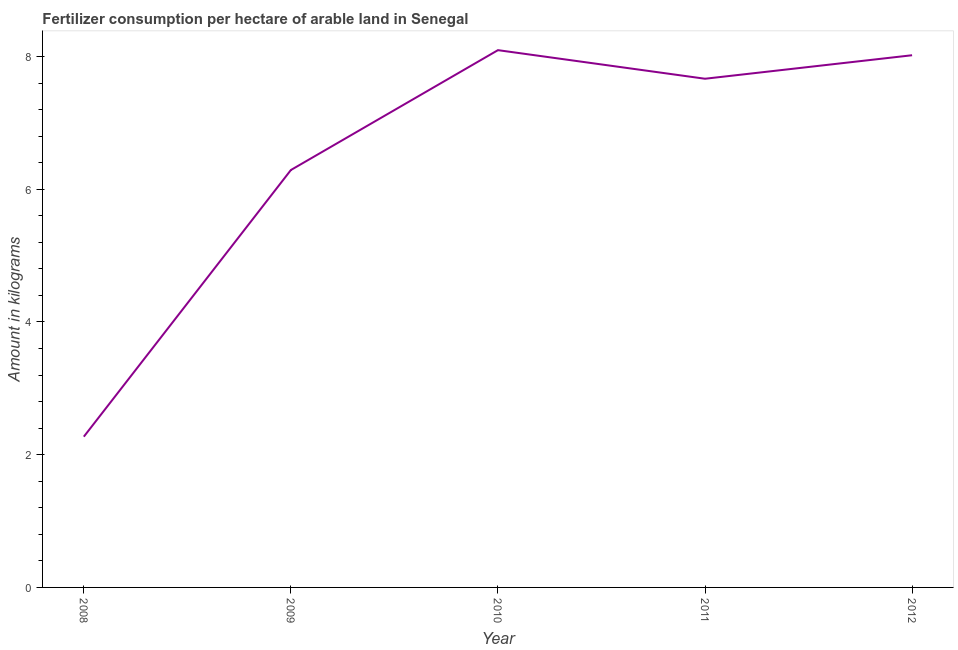What is the amount of fertilizer consumption in 2009?
Keep it short and to the point. 6.29. Across all years, what is the maximum amount of fertilizer consumption?
Provide a succinct answer. 8.1. Across all years, what is the minimum amount of fertilizer consumption?
Make the answer very short. 2.27. In which year was the amount of fertilizer consumption maximum?
Offer a very short reply. 2010. In which year was the amount of fertilizer consumption minimum?
Provide a succinct answer. 2008. What is the sum of the amount of fertilizer consumption?
Give a very brief answer. 32.34. What is the difference between the amount of fertilizer consumption in 2008 and 2011?
Your answer should be compact. -5.39. What is the average amount of fertilizer consumption per year?
Keep it short and to the point. 6.47. What is the median amount of fertilizer consumption?
Offer a very short reply. 7.67. In how many years, is the amount of fertilizer consumption greater than 6.4 kg?
Make the answer very short. 3. What is the ratio of the amount of fertilizer consumption in 2009 to that in 2010?
Your answer should be compact. 0.78. Is the amount of fertilizer consumption in 2008 less than that in 2011?
Ensure brevity in your answer.  Yes. What is the difference between the highest and the second highest amount of fertilizer consumption?
Your answer should be compact. 0.08. What is the difference between the highest and the lowest amount of fertilizer consumption?
Ensure brevity in your answer.  5.82. How many lines are there?
Offer a terse response. 1. What is the title of the graph?
Your response must be concise. Fertilizer consumption per hectare of arable land in Senegal . What is the label or title of the Y-axis?
Offer a terse response. Amount in kilograms. What is the Amount in kilograms in 2008?
Keep it short and to the point. 2.27. What is the Amount in kilograms in 2009?
Your answer should be compact. 6.29. What is the Amount in kilograms of 2010?
Make the answer very short. 8.1. What is the Amount in kilograms of 2011?
Offer a very short reply. 7.67. What is the Amount in kilograms in 2012?
Give a very brief answer. 8.02. What is the difference between the Amount in kilograms in 2008 and 2009?
Offer a terse response. -4.02. What is the difference between the Amount in kilograms in 2008 and 2010?
Provide a short and direct response. -5.82. What is the difference between the Amount in kilograms in 2008 and 2011?
Give a very brief answer. -5.39. What is the difference between the Amount in kilograms in 2008 and 2012?
Give a very brief answer. -5.75. What is the difference between the Amount in kilograms in 2009 and 2010?
Provide a succinct answer. -1.81. What is the difference between the Amount in kilograms in 2009 and 2011?
Provide a short and direct response. -1.38. What is the difference between the Amount in kilograms in 2009 and 2012?
Make the answer very short. -1.73. What is the difference between the Amount in kilograms in 2010 and 2011?
Offer a terse response. 0.43. What is the difference between the Amount in kilograms in 2010 and 2012?
Provide a short and direct response. 0.08. What is the difference between the Amount in kilograms in 2011 and 2012?
Provide a succinct answer. -0.35. What is the ratio of the Amount in kilograms in 2008 to that in 2009?
Ensure brevity in your answer.  0.36. What is the ratio of the Amount in kilograms in 2008 to that in 2010?
Provide a succinct answer. 0.28. What is the ratio of the Amount in kilograms in 2008 to that in 2011?
Give a very brief answer. 0.3. What is the ratio of the Amount in kilograms in 2008 to that in 2012?
Offer a very short reply. 0.28. What is the ratio of the Amount in kilograms in 2009 to that in 2010?
Your answer should be compact. 0.78. What is the ratio of the Amount in kilograms in 2009 to that in 2011?
Ensure brevity in your answer.  0.82. What is the ratio of the Amount in kilograms in 2009 to that in 2012?
Your response must be concise. 0.78. What is the ratio of the Amount in kilograms in 2010 to that in 2011?
Make the answer very short. 1.06. What is the ratio of the Amount in kilograms in 2010 to that in 2012?
Give a very brief answer. 1.01. What is the ratio of the Amount in kilograms in 2011 to that in 2012?
Your answer should be very brief. 0.96. 